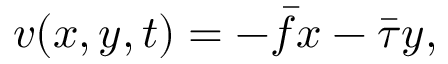<formula> <loc_0><loc_0><loc_500><loc_500>{ v } ( x , y , t ) = - \bar { f } x - \bar { \tau } y ,</formula> 